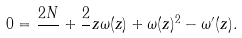Convert formula to latex. <formula><loc_0><loc_0><loc_500><loc_500>0 = \frac { 2 N } { } + \frac { 2 } { } z \omega ( z ) + \omega ( z ) ^ { 2 } - \omega ^ { \prime } ( z ) .</formula> 